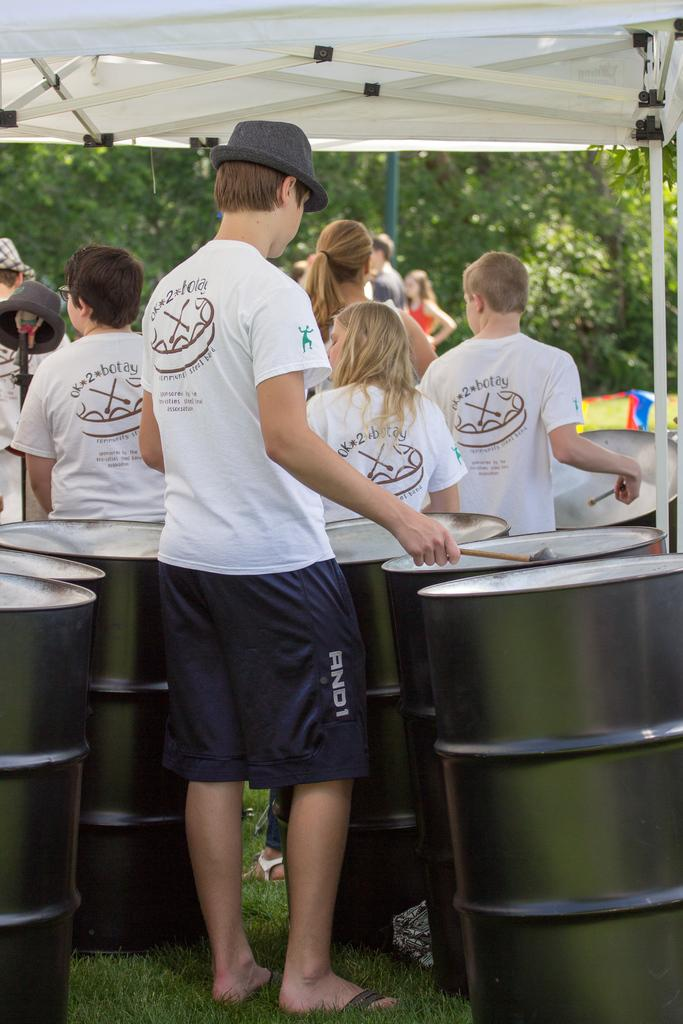<image>
Describe the image concisely. Several teens wear "OK 2 Botay" shirts at an event. 